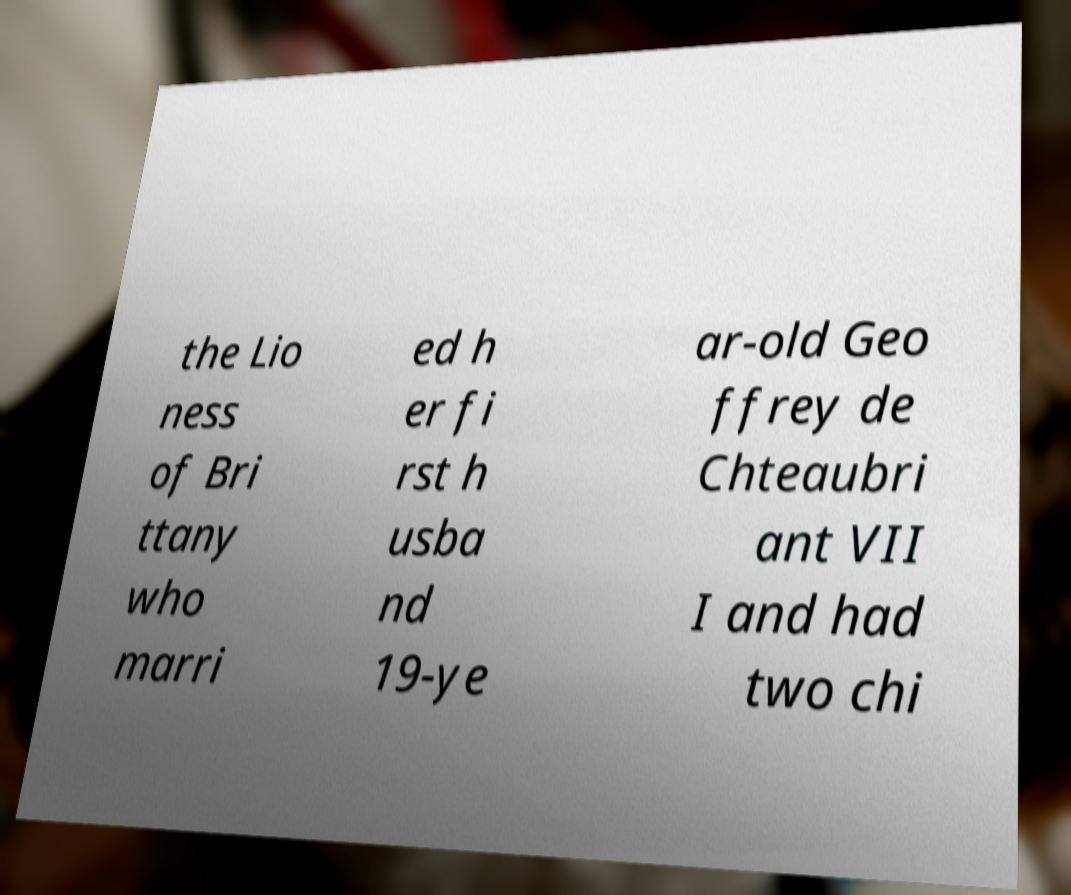Could you assist in decoding the text presented in this image and type it out clearly? the Lio ness of Bri ttany who marri ed h er fi rst h usba nd 19-ye ar-old Geo ffrey de Chteaubri ant VII I and had two chi 